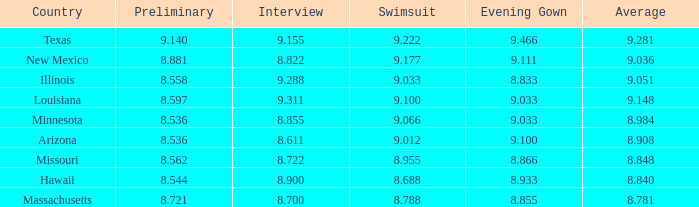What was the swimsuit score for the country with the average score of 8.848? 8.955. 